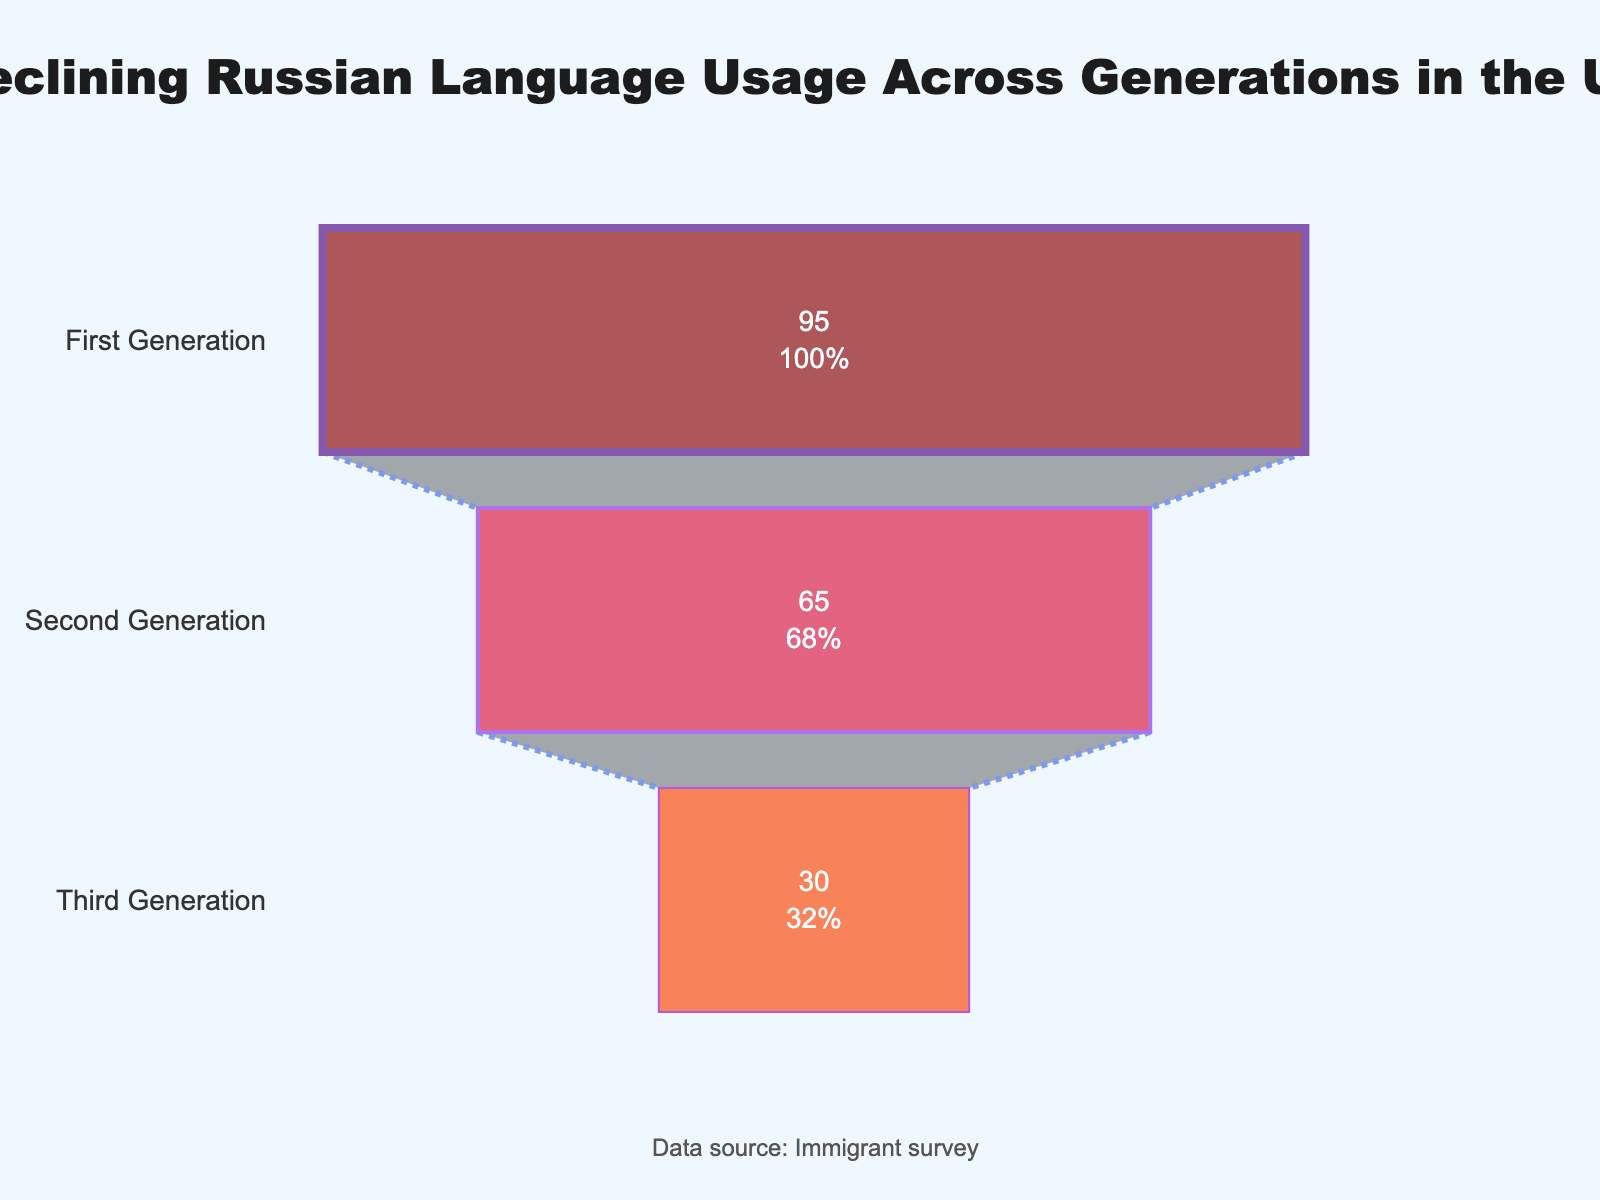What is the title of the figure? Look at the top of the figure to find the text that summarizes the main topic of the plot.
Answer: Declining Russian Language Usage Across Generations in the US How many generations are represented in the figure? Identify the number of distinct labels along the y-axis of the funnel chart.
Answer: 3 What is the Russian language usage percentage for the First Generation? Directly read the percentage value from the segment labeled "First Generation."
Answer: 95% What color is used to represent the Third Generation? Note the color of the segment labeled "Third Generation" in the funnel chart.
Answer: Orange What is the annotation at the bottom of the figure? Read the text provided under the plot.
Answer: Data source: Immigrant survey What is the average Russian language usage percentage across all three generations? Calculate the average by summing the percentages (95 + 65 + 30) and dividing by the number of data points (3).
Answer: 63.33% How much does the language usage percentage decrease from the First to the Third Generation? Subtract the Third Generation's percentage from the First Generation's percentage (95 - 30).
Answer: 65% What is the percentage point difference in Russian language usage between the Second and Third Generation? Subtract the Third Generation's percentage from the Second Generation's percentage (65 - 30).
Answer: 35% Which generation has the lowest Russian language usage percentage? Identify the generation with the smallest percentage value in the funnel chart.
Answer: Third Generation How does the Russian language usage percentage of the Second Generation compare to the First Generation? Compare the percentages of the Second Generation (65) and the First Generation (95) to determine if it is lower, higher, or equal.
Answer: Lower 